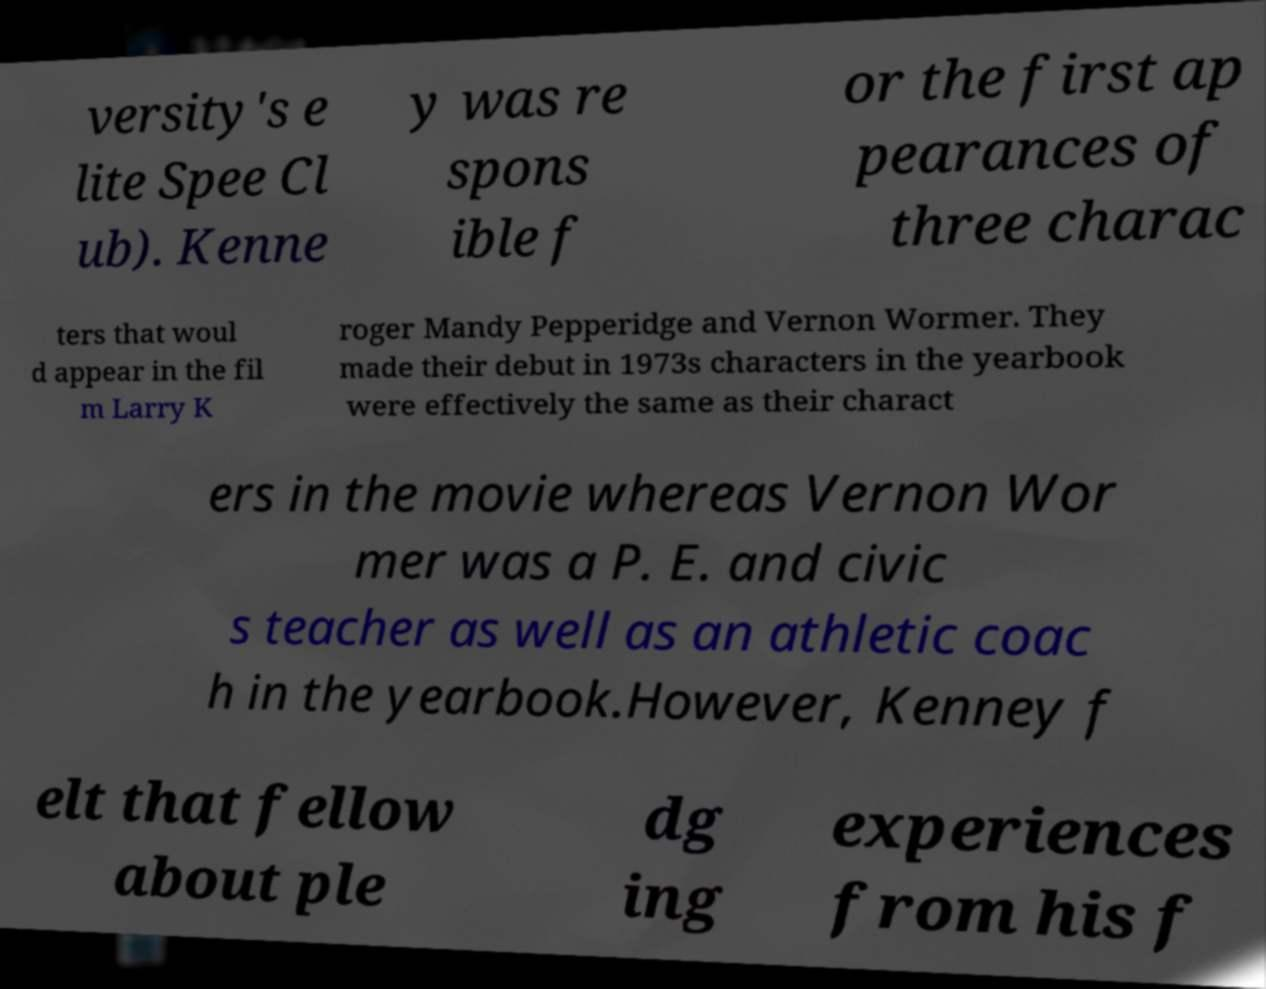Please read and relay the text visible in this image. What does it say? versity's e lite Spee Cl ub). Kenne y was re spons ible f or the first ap pearances of three charac ters that woul d appear in the fil m Larry K roger Mandy Pepperidge and Vernon Wormer. They made their debut in 1973s characters in the yearbook were effectively the same as their charact ers in the movie whereas Vernon Wor mer was a P. E. and civic s teacher as well as an athletic coac h in the yearbook.However, Kenney f elt that fellow about ple dg ing experiences from his f 